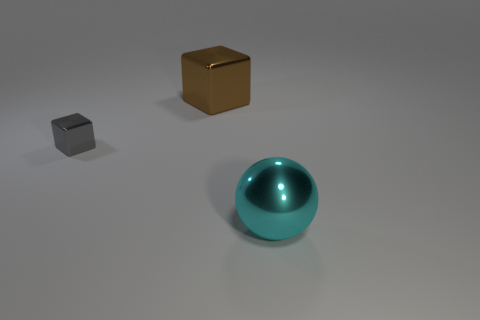Is there any other thing that is the same shape as the large cyan thing?
Your answer should be compact. No. Is the number of tiny things greater than the number of red metal balls?
Provide a succinct answer. Yes. How many objects are brown metallic spheres or large metallic objects that are on the left side of the metallic ball?
Offer a very short reply. 1. Do the brown metal thing and the cyan ball have the same size?
Provide a short and direct response. Yes. There is a large brown thing; are there any tiny gray metal things in front of it?
Provide a short and direct response. Yes. What size is the object that is right of the small gray shiny cube and behind the cyan shiny object?
Keep it short and to the point. Large. What number of things are gray shiny blocks or big cyan shiny balls?
Provide a succinct answer. 2. There is a brown thing; is it the same size as the metallic thing that is to the right of the large brown metallic block?
Ensure brevity in your answer.  Yes. There is a block behind the tiny block in front of the block that is behind the gray block; what is its size?
Offer a very short reply. Large. Are any green rubber spheres visible?
Your response must be concise. No. 